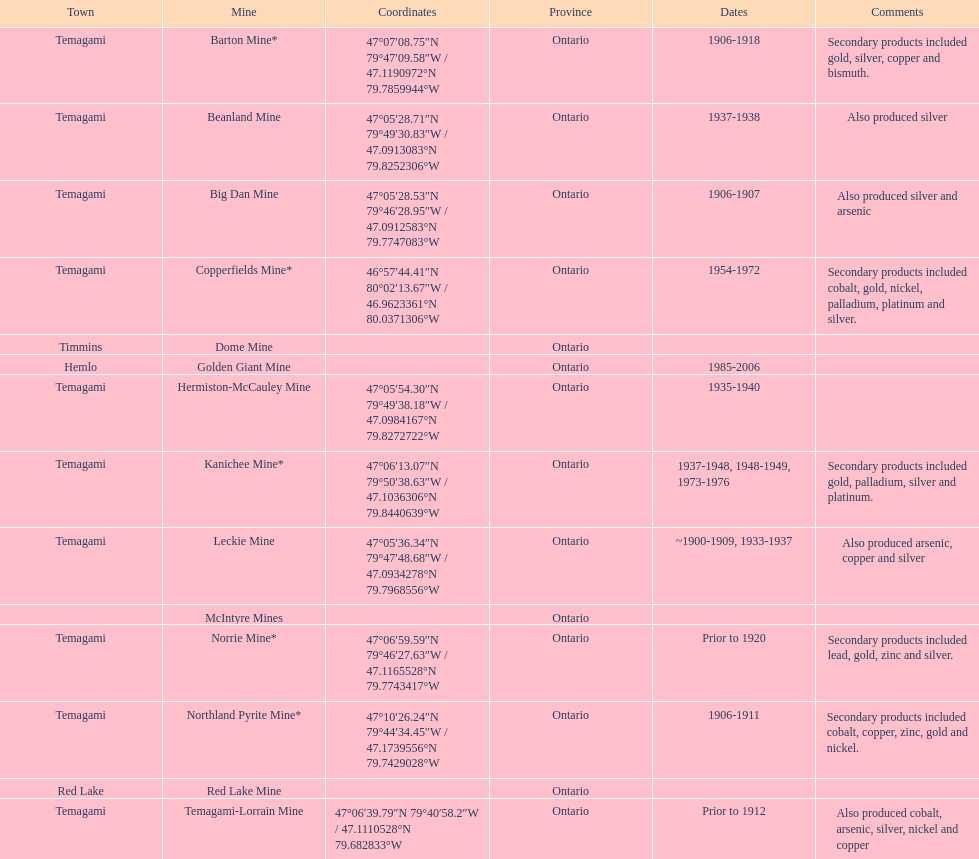Could you help me parse every detail presented in this table? {'header': ['Town', 'Mine', 'Coordinates', 'Province', 'Dates', 'Comments'], 'rows': [['Temagami', 'Barton Mine*', '47°07′08.75″N 79°47′09.58″W\ufeff / \ufeff47.1190972°N 79.7859944°W', 'Ontario', '1906-1918', 'Secondary products included gold, silver, copper and bismuth.'], ['Temagami', 'Beanland Mine', '47°05′28.71″N 79°49′30.83″W\ufeff / \ufeff47.0913083°N 79.8252306°W', 'Ontario', '1937-1938', 'Also produced silver'], ['Temagami', 'Big Dan Mine', '47°05′28.53″N 79°46′28.95″W\ufeff / \ufeff47.0912583°N 79.7747083°W', 'Ontario', '1906-1907', 'Also produced silver and arsenic'], ['Temagami', 'Copperfields Mine*', '46°57′44.41″N 80°02′13.67″W\ufeff / \ufeff46.9623361°N 80.0371306°W', 'Ontario', '1954-1972', 'Secondary products included cobalt, gold, nickel, palladium, platinum and silver.'], ['Timmins', 'Dome Mine', '', 'Ontario', '', ''], ['Hemlo', 'Golden Giant Mine', '', 'Ontario', '1985-2006', ''], ['Temagami', 'Hermiston-McCauley Mine', '47°05′54.30″N 79°49′38.18″W\ufeff / \ufeff47.0984167°N 79.8272722°W', 'Ontario', '1935-1940', ''], ['Temagami', 'Kanichee Mine*', '47°06′13.07″N 79°50′38.63″W\ufeff / \ufeff47.1036306°N 79.8440639°W', 'Ontario', '1937-1948, 1948-1949, 1973-1976', 'Secondary products included gold, palladium, silver and platinum.'], ['Temagami', 'Leckie Mine', '47°05′36.34″N 79°47′48.68″W\ufeff / \ufeff47.0934278°N 79.7968556°W', 'Ontario', '~1900-1909, 1933-1937', 'Also produced arsenic, copper and silver'], ['', 'McIntyre Mines', '', 'Ontario', '', ''], ['Temagami', 'Norrie Mine*', '47°06′59.59″N 79°46′27.63″W\ufeff / \ufeff47.1165528°N 79.7743417°W', 'Ontario', 'Prior to 1920', 'Secondary products included lead, gold, zinc and silver.'], ['Temagami', 'Northland Pyrite Mine*', '47°10′26.24″N 79°44′34.45″W\ufeff / \ufeff47.1739556°N 79.7429028°W', 'Ontario', '1906-1911', 'Secondary products included cobalt, copper, zinc, gold and nickel.'], ['Red Lake', 'Red Lake Mine', '', 'Ontario', '', ''], ['Temagami', 'Temagami-Lorrain Mine', '47°06′39.79″N 79°40′58.2″W\ufeff / \ufeff47.1110528°N 79.682833°W', 'Ontario', 'Prior to 1912', 'Also produced cobalt, arsenic, silver, nickel and copper']]} Identify a gold mine that was operational for at least a decade. Barton Mine. 